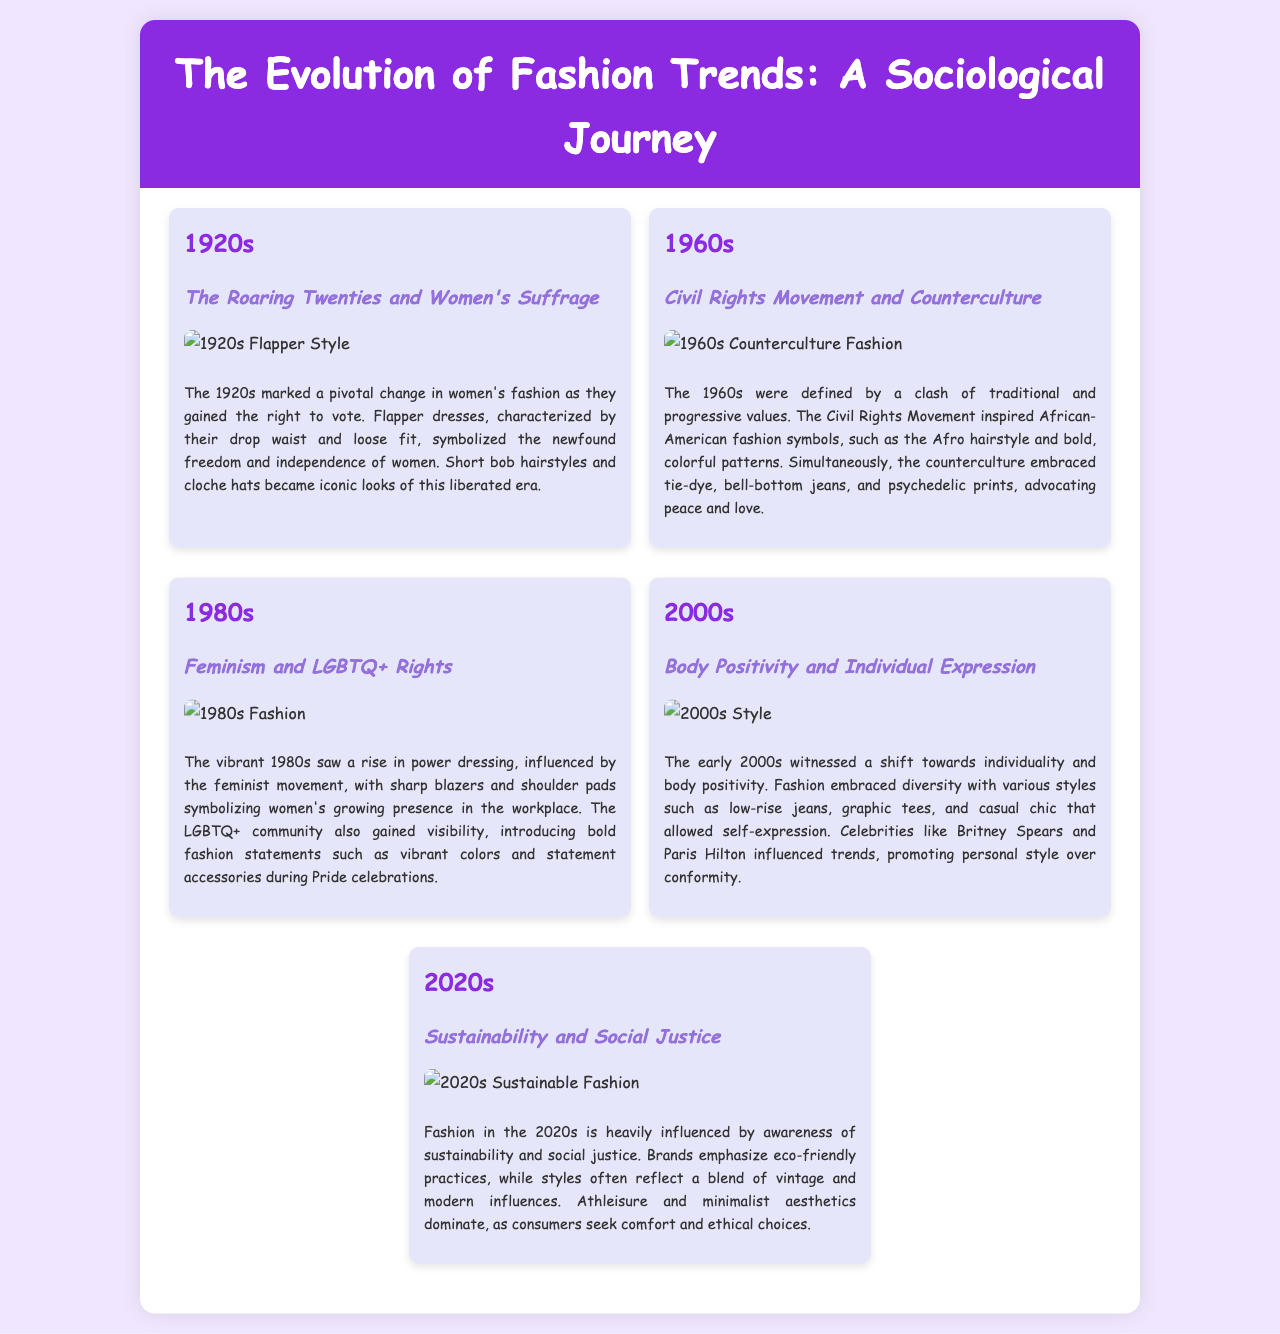What was a significant fashion style in the 1920s? The significant fashion style in the 1920s was flapper dresses, which symbolized women's newfound freedom and independence.
Answer: flapper dresses What hairstyle became iconic in the 1920s? The hairstyle that became iconic in the 1920s was the bob hairstyle, accompanied by cloche hats.
Answer: bob hairstyle Which social movement influenced the fashion of the 1960s? The Civil Rights Movement significantly influenced fashion during the 1960s, inspiring African-American fashion symbols and styles.
Answer: Civil Rights Movement What type of clothing defined the power dressing in the 1980s? The power dressing in the 1980s was defined by sharp blazers and shoulder pads, symbolizing women's presence in the workplace.
Answer: sharp blazers and shoulder pads What is a key theme in 2020s fashion trends? A key theme in 2020s fashion trends is sustainability, with brands emphasizing eco-friendly practices and ethical choices.
Answer: sustainability Which celebrity influenced trends in the early 2000s? Britney Spears influenced trends in the early 2000s, promoting personal style over conformity.
Answer: Britney Spears What was a dominant fashion style of the 2000s? A dominant fashion style of the 2000s included low-rise jeans, graphic tees, and casual chic elements.
Answer: low-rise jeans, graphic tees, and casual chic What era's fashion focused on individuality and body positivity? The fashion that focused on individuality and body positivity was primarily seen in the early 2000s.
Answer: early 2000s Which modern aesthetic is prevalent in the 2020s? The modern aesthetic prevalent in the 2020s is minimalism, focusing on comfort and ethical choices.
Answer: minimalism 